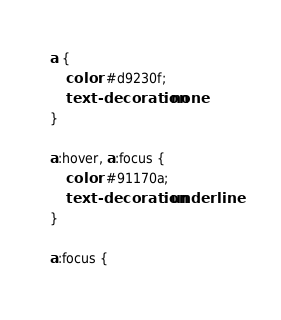Convert code to text. <code><loc_0><loc_0><loc_500><loc_500><_CSS_>a {
    color: #d9230f;
    text-decoration: none
}

a:hover, a:focus {
    color: #91170a;
    text-decoration: underline
}

a:focus {</code> 